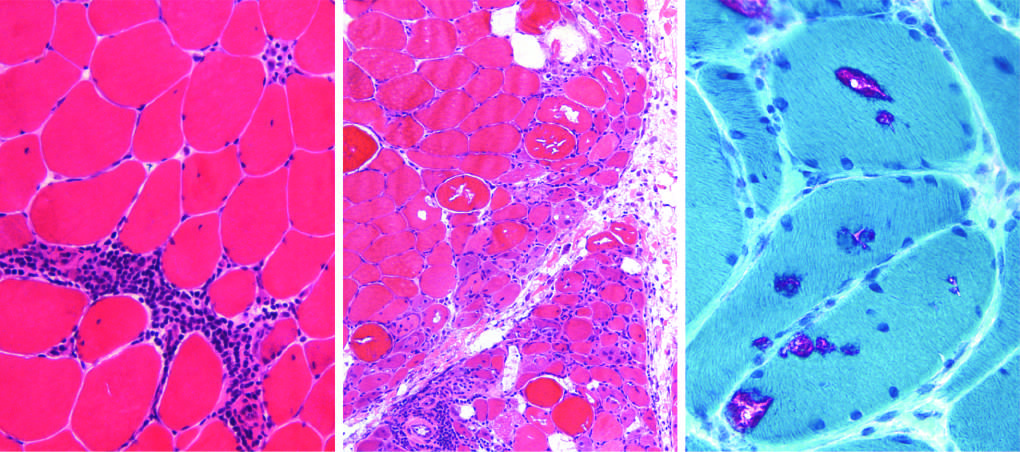s the distal hepatic tissue stain modified?
Answer the question using a single word or phrase. No 